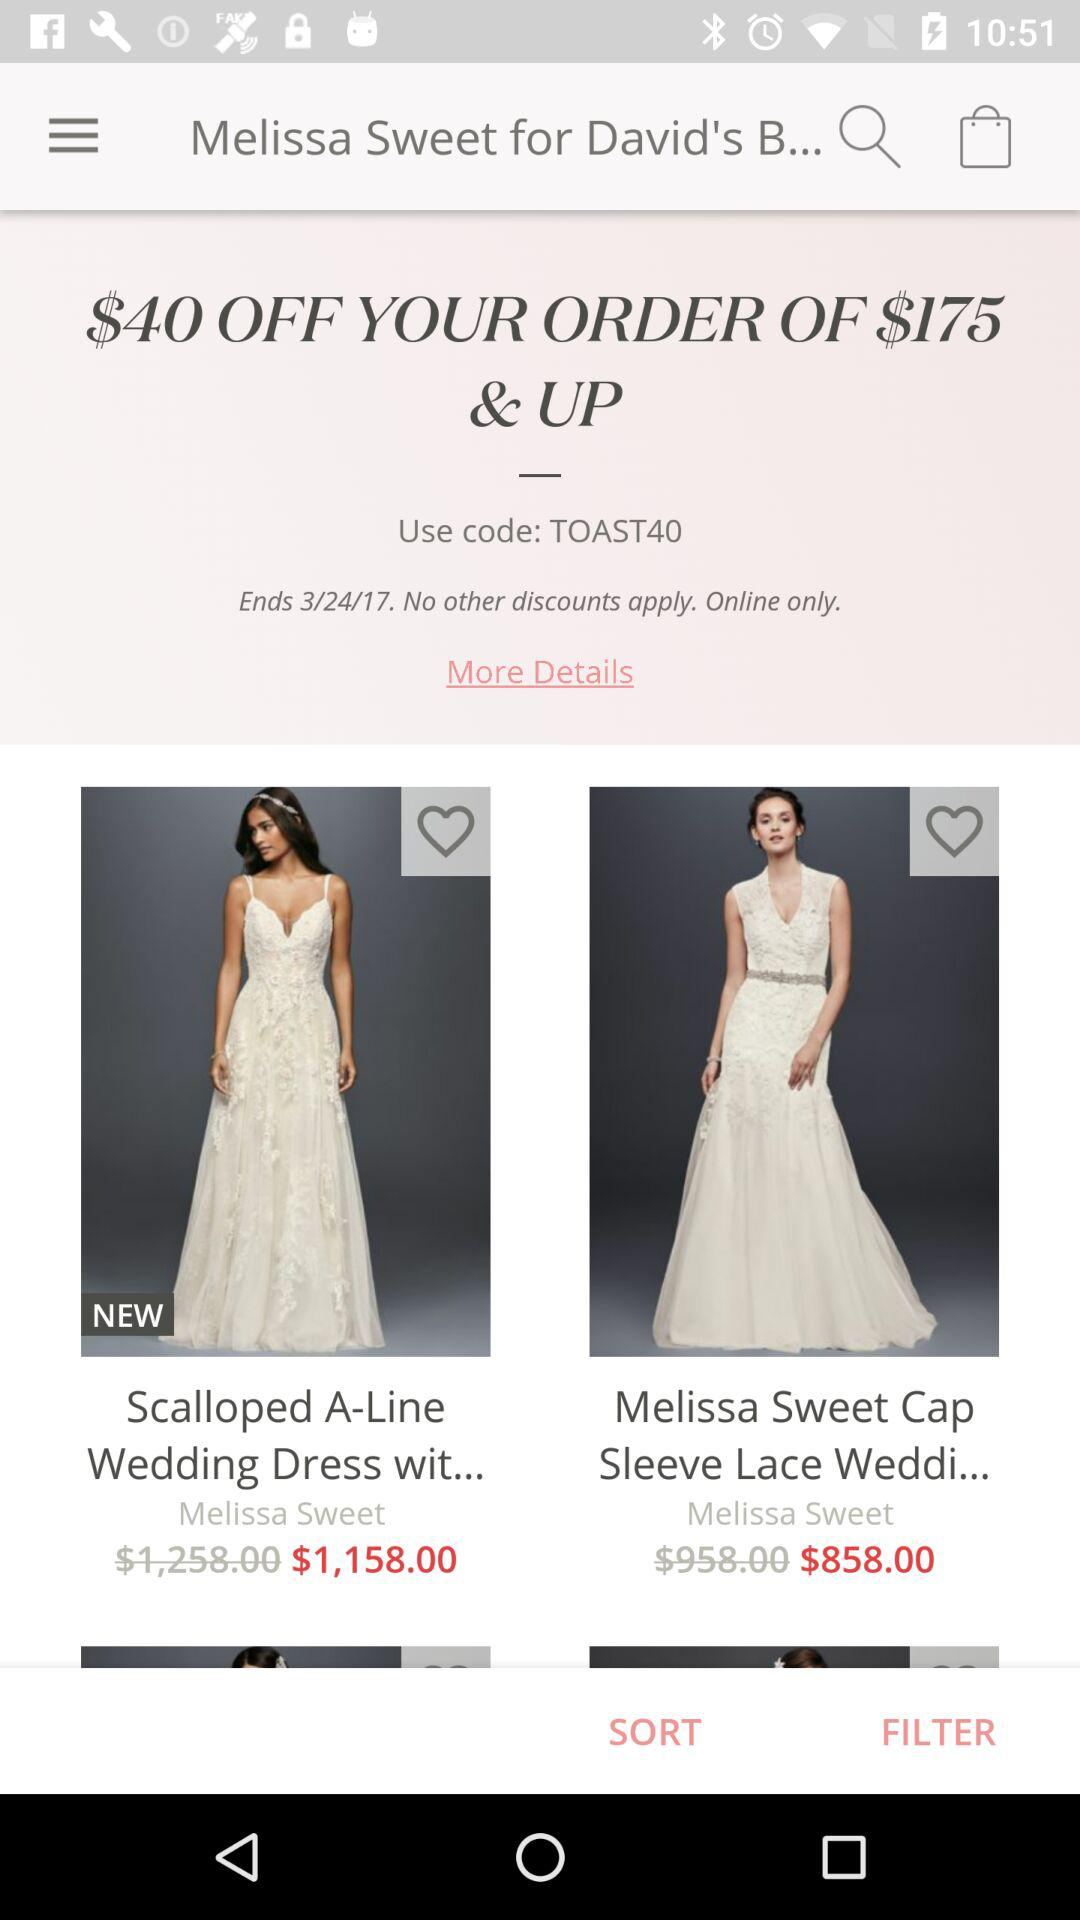When is the offer ending? The offer is ending on March 24, 2017. 